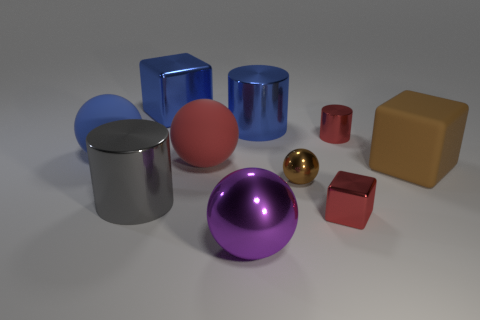There is a large metal cube; does it have the same color as the big shiny cylinder that is behind the tiny brown shiny sphere?
Keep it short and to the point. Yes. What is the shape of the tiny brown metal object?
Your response must be concise. Sphere. How many other things are there of the same shape as the big brown rubber thing?
Offer a very short reply. 2. The rubber object on the right side of the large purple metallic thing is what color?
Offer a terse response. Brown. Are the large blue cylinder and the red sphere made of the same material?
Ensure brevity in your answer.  No. How many objects are small red shiny objects or big blocks to the right of the tiny shiny cylinder?
Keep it short and to the point. 3. There is a metal sphere that is the same color as the big matte cube; what size is it?
Keep it short and to the point. Small. The red thing that is in front of the big brown matte thing has what shape?
Your answer should be very brief. Cube. There is a cube that is in front of the brown metal thing; is its color the same as the tiny metallic cylinder?
Your response must be concise. Yes. What material is the small cylinder that is the same color as the tiny cube?
Your answer should be very brief. Metal. 